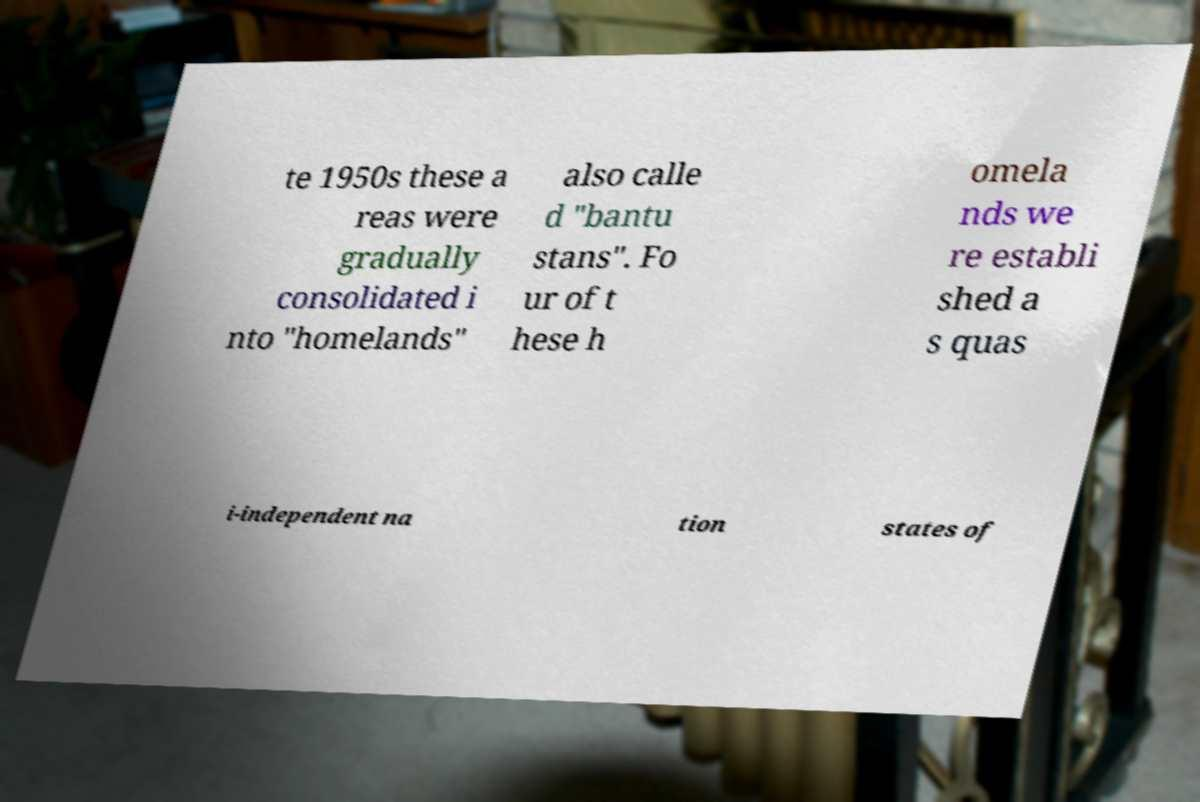Could you extract and type out the text from this image? te 1950s these a reas were gradually consolidated i nto "homelands" also calle d "bantu stans". Fo ur of t hese h omela nds we re establi shed a s quas i-independent na tion states of 